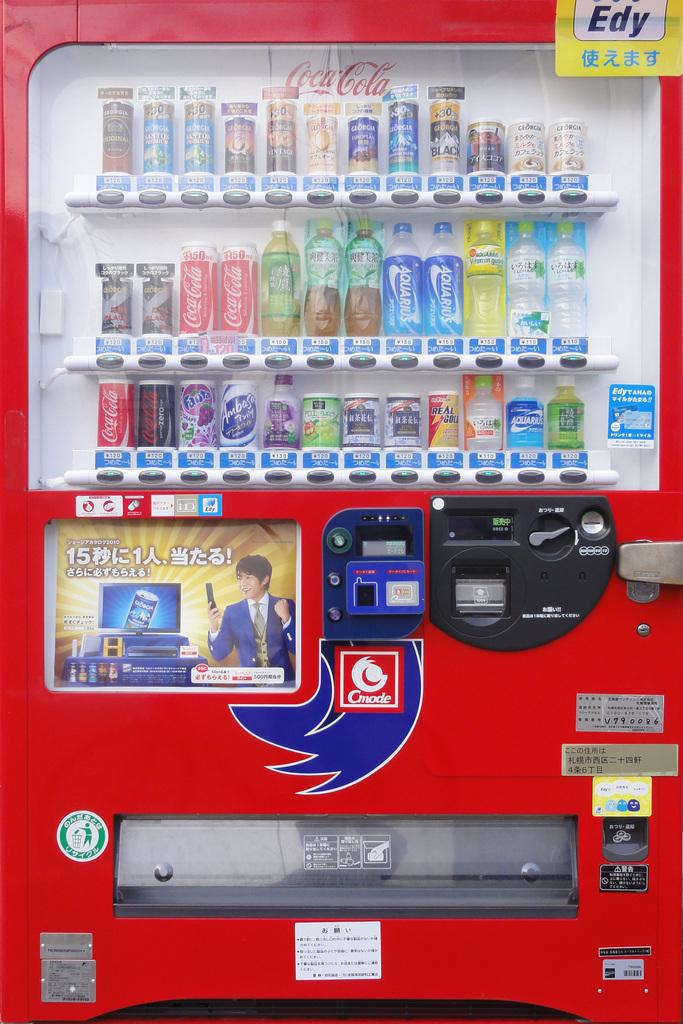<image>
Share a concise interpretation of the image provided. A red beverage vending machine that is sponsored by Coca Cola. 